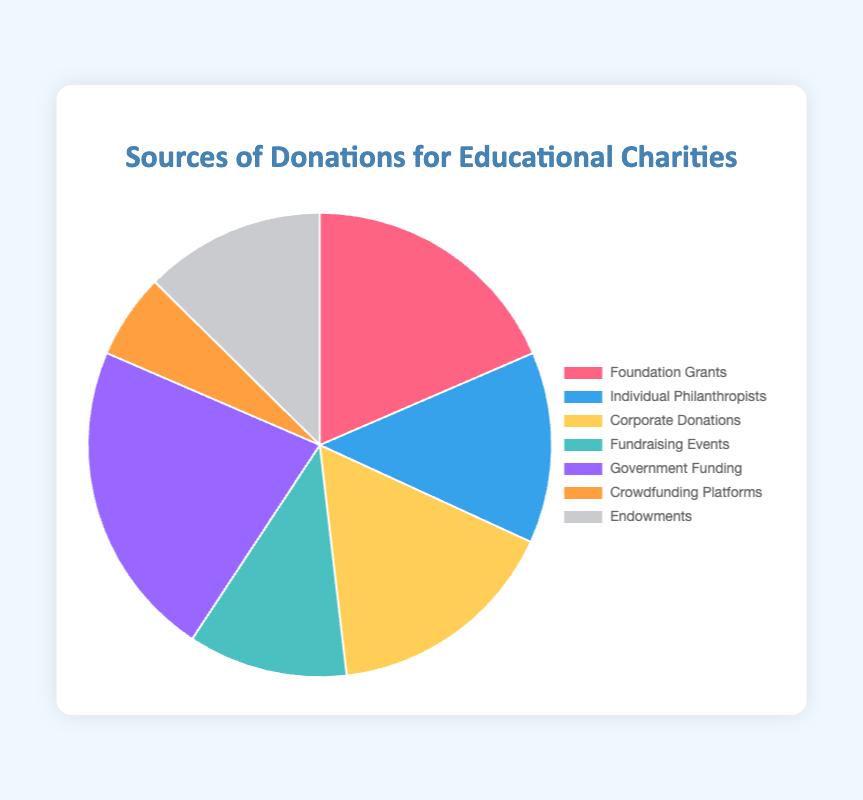What percentage of the total donations does the Government Funding represent? Government Funding amounts to $3,000,000. The total donations add up to $13,300,000. To find the percentage, divide $3,000,000 by $13,300,000 and multiply by 100: (3,000,000 / 13,300,000) * 100 ≈ 22.56%
Answer: 22.56% Which source of donations contributed the least amount? By looking at the pie chart, Crowdfunding Platforms contributed the least amount, which is $800,000.
Answer: Crowdfunding Platforms How much more did Foundations Grants contribute compared to Endowments? Foundation Grants amount to $2,500,000 and Endowments amount to $1,700,000. The difference is $2,500,000 - $1,700,000 = $800,000.
Answer: $800,000 Which donation sources contributed more than $2,000,000? The sources with donations more than $2,000,000 are Government Funding, Foundation Grants, and Corporate Donations.
Answer: Government Funding, Foundation Grants, Corporate Donations How much total funding is received from Corporate Donations and Fundraising Events combined? Corporate Donations amount to $2,200,000, and Fundraising Events amount to $1,500,000. Their combined total is $2,200,000 + $1,500,000 = $3,700,000.
Answer: $3,700,000 What proportion of the donations come from Individual Philanthropists and Crowdfunding Platforms combined? Individual Philanthropists contribute $1,800,000 and Crowdfunding Platforms contribute $800,000. Their combined amount is $2,600,000. The total donations are $13,300,000. The proportion is $2,600,000 / $13,300,000 ≈ 0.1955.
Answer: 19.55% Identify two sources of donations with nearly equal contributions. Corporate Donations amount to $2,200,000 and Foundation Grants amount to $2,500,000. The difference between them is $300,000, making them nearly equal.
Answer: Corporate Donations and Foundation Grants What is the donation amount from Fundraising Events as a percentage of that from Individual Philanthropists? Fundraising Events raise $1,500,000 and Individual Philanthropists raise $1,800,000. The percentage is ($1,500,000 / $1,800,000) * 100 ≈ 83.33%.
Answer: 83.33% Which color corresponds to the Government Funding in the pie chart? Government Funding is represented by the color purple in the pie chart.
Answer: Purple What is the combined contribution of sources providing less than $2,000,000 each? The sources contributing less than $2,000,000 are Individual Philanthropists ($1,800,000), Fundraising Events ($1,500,000), Crowdfunding Platforms ($800,000), and Endowments ($1,700,000). Their combined total is $1,800,000 + $1,500,000 + $800,000 + $1,700,000 = $5,800,000.
Answer: $5,800,000 